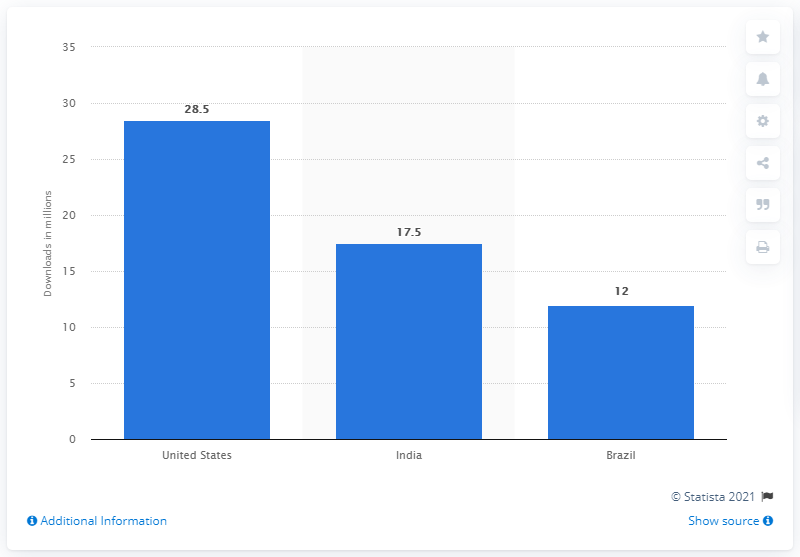List a handful of essential elements in this visual. The downloads were primarily from the United States, with 28.5 million of them. 